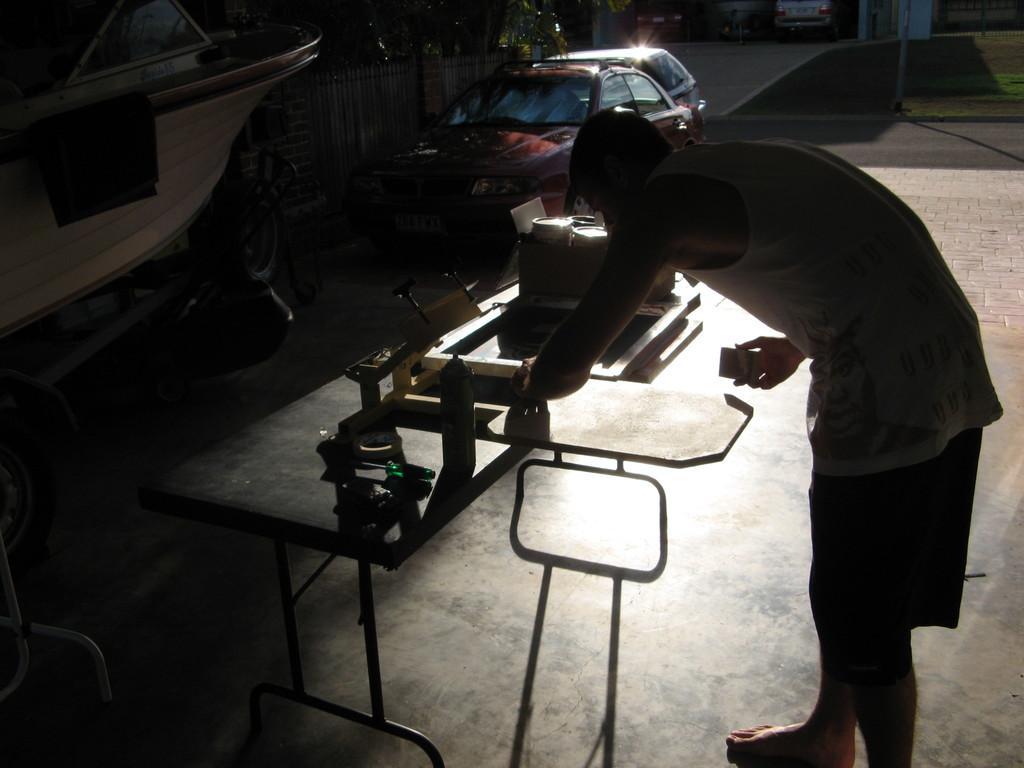Could you give a brief overview of what you see in this image? This man is standing in-front of this table, on this table there are things. Beside this vehicle's there is a fence. Beside this fence there are trees. 